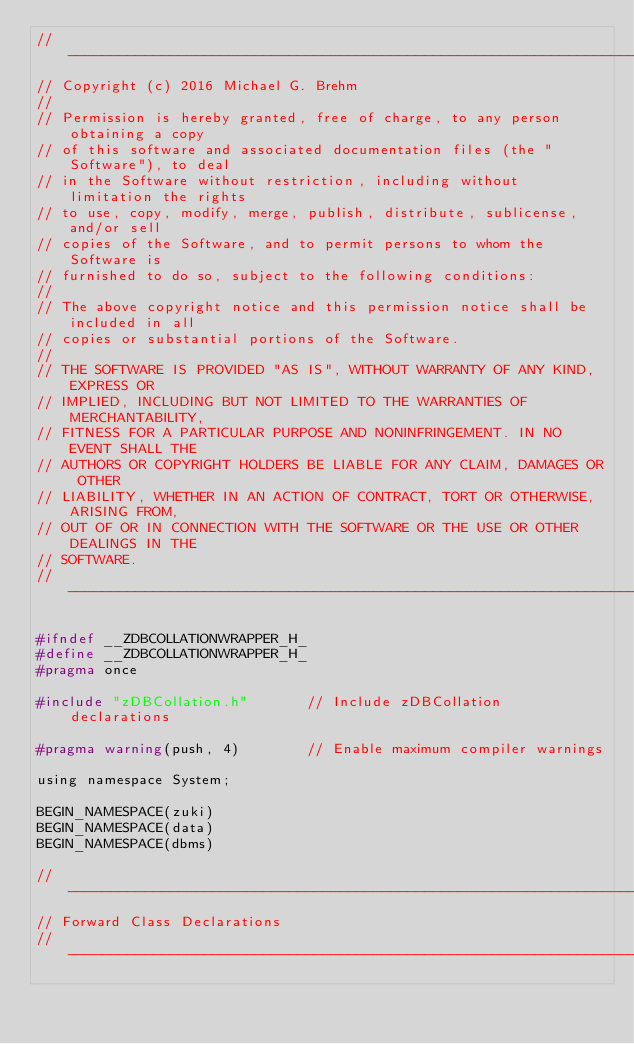Convert code to text. <code><loc_0><loc_0><loc_500><loc_500><_C_>//---------------------------------------------------------------------------
// Copyright (c) 2016 Michael G. Brehm
// 
// Permission is hereby granted, free of charge, to any person obtaining a copy
// of this software and associated documentation files (the "Software"), to deal
// in the Software without restriction, including without limitation the rights
// to use, copy, modify, merge, publish, distribute, sublicense, and/or sell
// copies of the Software, and to permit persons to whom the Software is
// furnished to do so, subject to the following conditions:
// 
// The above copyright notice and this permission notice shall be included in all
// copies or substantial portions of the Software.
// 
// THE SOFTWARE IS PROVIDED "AS IS", WITHOUT WARRANTY OF ANY KIND, EXPRESS OR
// IMPLIED, INCLUDING BUT NOT LIMITED TO THE WARRANTIES OF MERCHANTABILITY,
// FITNESS FOR A PARTICULAR PURPOSE AND NONINFRINGEMENT. IN NO EVENT SHALL THE
// AUTHORS OR COPYRIGHT HOLDERS BE LIABLE FOR ANY CLAIM, DAMAGES OR OTHER
// LIABILITY, WHETHER IN AN ACTION OF CONTRACT, TORT OR OTHERWISE, ARISING FROM,
// OUT OF OR IN CONNECTION WITH THE SOFTWARE OR THE USE OR OTHER DEALINGS IN THE
// SOFTWARE.
//---------------------------------------------------------------------------

#ifndef __ZDBCOLLATIONWRAPPER_H_
#define __ZDBCOLLATIONWRAPPER_H_
#pragma once

#include "zDBCollation.h"				// Include zDBCollation declarations

#pragma warning(push, 4)				// Enable maximum compiler warnings

using namespace System;

BEGIN_NAMESPACE(zuki)
BEGIN_NAMESPACE(data)
BEGIN_NAMESPACE(dbms)

//---------------------------------------------------------------------------
// Forward Class Declarations
//---------------------------------------------------------------------------
</code> 